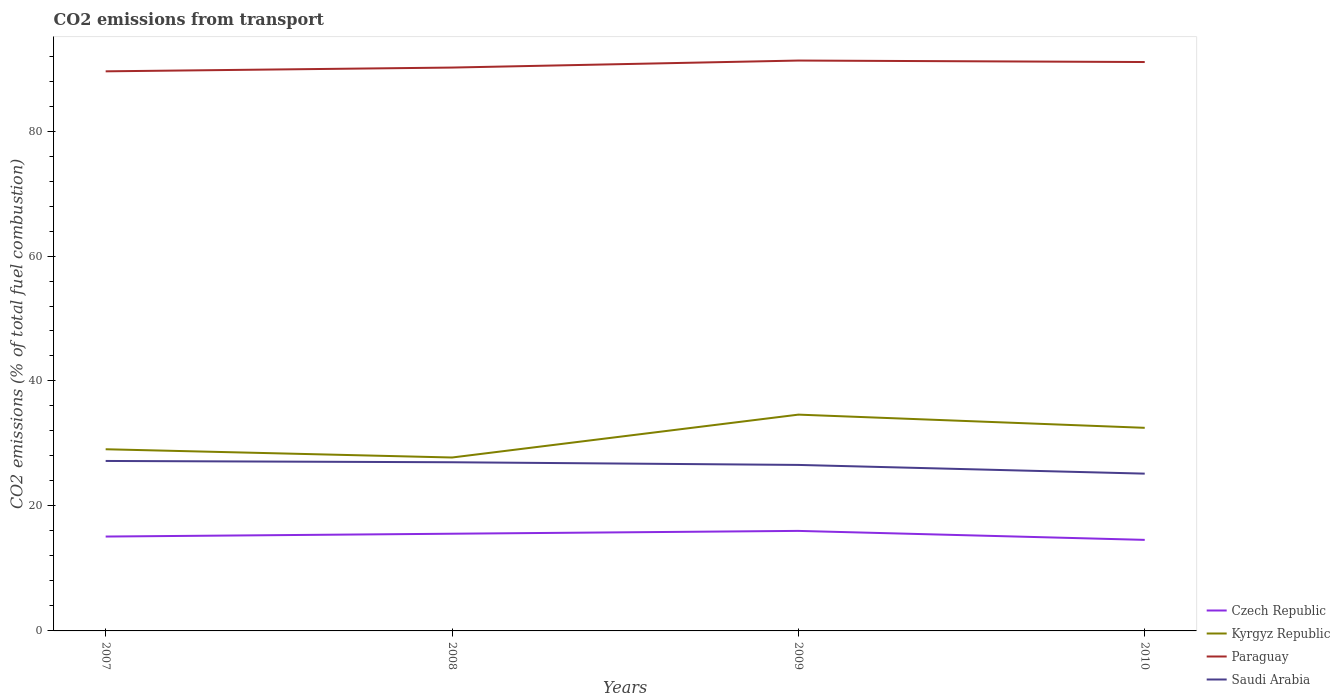How many different coloured lines are there?
Your answer should be compact. 4. Is the number of lines equal to the number of legend labels?
Your answer should be very brief. Yes. Across all years, what is the maximum total CO2 emitted in Saudi Arabia?
Offer a very short reply. 25.17. In which year was the total CO2 emitted in Czech Republic maximum?
Your response must be concise. 2010. What is the total total CO2 emitted in Czech Republic in the graph?
Your response must be concise. -0.45. What is the difference between the highest and the second highest total CO2 emitted in Saudi Arabia?
Provide a short and direct response. 2.03. How many years are there in the graph?
Make the answer very short. 4. Are the values on the major ticks of Y-axis written in scientific E-notation?
Make the answer very short. No. Does the graph contain any zero values?
Ensure brevity in your answer.  No. Does the graph contain grids?
Give a very brief answer. No. Where does the legend appear in the graph?
Provide a short and direct response. Bottom right. How many legend labels are there?
Keep it short and to the point. 4. How are the legend labels stacked?
Your response must be concise. Vertical. What is the title of the graph?
Keep it short and to the point. CO2 emissions from transport. What is the label or title of the X-axis?
Your answer should be very brief. Years. What is the label or title of the Y-axis?
Your answer should be compact. CO2 emissions (% of total fuel combustion). What is the CO2 emissions (% of total fuel combustion) in Czech Republic in 2007?
Your answer should be compact. 15.1. What is the CO2 emissions (% of total fuel combustion) in Kyrgyz Republic in 2007?
Offer a terse response. 29.08. What is the CO2 emissions (% of total fuel combustion) in Paraguay in 2007?
Provide a succinct answer. 89.56. What is the CO2 emissions (% of total fuel combustion) in Saudi Arabia in 2007?
Make the answer very short. 27.2. What is the CO2 emissions (% of total fuel combustion) in Czech Republic in 2008?
Your response must be concise. 15.56. What is the CO2 emissions (% of total fuel combustion) of Kyrgyz Republic in 2008?
Offer a terse response. 27.75. What is the CO2 emissions (% of total fuel combustion) in Paraguay in 2008?
Provide a short and direct response. 90.16. What is the CO2 emissions (% of total fuel combustion) of Saudi Arabia in 2008?
Offer a terse response. 26.99. What is the CO2 emissions (% of total fuel combustion) in Czech Republic in 2009?
Keep it short and to the point. 16.01. What is the CO2 emissions (% of total fuel combustion) of Kyrgyz Republic in 2009?
Provide a succinct answer. 34.62. What is the CO2 emissions (% of total fuel combustion) in Paraguay in 2009?
Provide a succinct answer. 91.28. What is the CO2 emissions (% of total fuel combustion) in Saudi Arabia in 2009?
Offer a terse response. 26.57. What is the CO2 emissions (% of total fuel combustion) of Czech Republic in 2010?
Keep it short and to the point. 14.57. What is the CO2 emissions (% of total fuel combustion) of Kyrgyz Republic in 2010?
Your answer should be compact. 32.5. What is the CO2 emissions (% of total fuel combustion) of Paraguay in 2010?
Give a very brief answer. 91.04. What is the CO2 emissions (% of total fuel combustion) in Saudi Arabia in 2010?
Your response must be concise. 25.17. Across all years, what is the maximum CO2 emissions (% of total fuel combustion) of Czech Republic?
Ensure brevity in your answer.  16.01. Across all years, what is the maximum CO2 emissions (% of total fuel combustion) of Kyrgyz Republic?
Provide a succinct answer. 34.62. Across all years, what is the maximum CO2 emissions (% of total fuel combustion) of Paraguay?
Give a very brief answer. 91.28. Across all years, what is the maximum CO2 emissions (% of total fuel combustion) in Saudi Arabia?
Give a very brief answer. 27.2. Across all years, what is the minimum CO2 emissions (% of total fuel combustion) of Czech Republic?
Make the answer very short. 14.57. Across all years, what is the minimum CO2 emissions (% of total fuel combustion) of Kyrgyz Republic?
Offer a very short reply. 27.75. Across all years, what is the minimum CO2 emissions (% of total fuel combustion) in Paraguay?
Your answer should be compact. 89.56. Across all years, what is the minimum CO2 emissions (% of total fuel combustion) of Saudi Arabia?
Provide a short and direct response. 25.17. What is the total CO2 emissions (% of total fuel combustion) in Czech Republic in the graph?
Your answer should be very brief. 61.24. What is the total CO2 emissions (% of total fuel combustion) of Kyrgyz Republic in the graph?
Ensure brevity in your answer.  123.95. What is the total CO2 emissions (% of total fuel combustion) in Paraguay in the graph?
Your response must be concise. 362.04. What is the total CO2 emissions (% of total fuel combustion) of Saudi Arabia in the graph?
Give a very brief answer. 105.93. What is the difference between the CO2 emissions (% of total fuel combustion) of Czech Republic in 2007 and that in 2008?
Keep it short and to the point. -0.45. What is the difference between the CO2 emissions (% of total fuel combustion) of Kyrgyz Republic in 2007 and that in 2008?
Ensure brevity in your answer.  1.32. What is the difference between the CO2 emissions (% of total fuel combustion) in Paraguay in 2007 and that in 2008?
Provide a succinct answer. -0.6. What is the difference between the CO2 emissions (% of total fuel combustion) of Saudi Arabia in 2007 and that in 2008?
Keep it short and to the point. 0.21. What is the difference between the CO2 emissions (% of total fuel combustion) in Czech Republic in 2007 and that in 2009?
Keep it short and to the point. -0.9. What is the difference between the CO2 emissions (% of total fuel combustion) in Kyrgyz Republic in 2007 and that in 2009?
Ensure brevity in your answer.  -5.54. What is the difference between the CO2 emissions (% of total fuel combustion) of Paraguay in 2007 and that in 2009?
Provide a short and direct response. -1.73. What is the difference between the CO2 emissions (% of total fuel combustion) in Saudi Arabia in 2007 and that in 2009?
Keep it short and to the point. 0.64. What is the difference between the CO2 emissions (% of total fuel combustion) of Czech Republic in 2007 and that in 2010?
Offer a very short reply. 0.53. What is the difference between the CO2 emissions (% of total fuel combustion) of Kyrgyz Republic in 2007 and that in 2010?
Ensure brevity in your answer.  -3.43. What is the difference between the CO2 emissions (% of total fuel combustion) in Paraguay in 2007 and that in 2010?
Ensure brevity in your answer.  -1.49. What is the difference between the CO2 emissions (% of total fuel combustion) of Saudi Arabia in 2007 and that in 2010?
Make the answer very short. 2.03. What is the difference between the CO2 emissions (% of total fuel combustion) in Czech Republic in 2008 and that in 2009?
Provide a short and direct response. -0.45. What is the difference between the CO2 emissions (% of total fuel combustion) in Kyrgyz Republic in 2008 and that in 2009?
Offer a terse response. -6.86. What is the difference between the CO2 emissions (% of total fuel combustion) in Paraguay in 2008 and that in 2009?
Your response must be concise. -1.12. What is the difference between the CO2 emissions (% of total fuel combustion) in Saudi Arabia in 2008 and that in 2009?
Provide a succinct answer. 0.43. What is the difference between the CO2 emissions (% of total fuel combustion) of Czech Republic in 2008 and that in 2010?
Your answer should be very brief. 0.99. What is the difference between the CO2 emissions (% of total fuel combustion) in Kyrgyz Republic in 2008 and that in 2010?
Provide a short and direct response. -4.75. What is the difference between the CO2 emissions (% of total fuel combustion) of Paraguay in 2008 and that in 2010?
Your answer should be very brief. -0.89. What is the difference between the CO2 emissions (% of total fuel combustion) of Saudi Arabia in 2008 and that in 2010?
Keep it short and to the point. 1.82. What is the difference between the CO2 emissions (% of total fuel combustion) of Czech Republic in 2009 and that in 2010?
Give a very brief answer. 1.44. What is the difference between the CO2 emissions (% of total fuel combustion) of Kyrgyz Republic in 2009 and that in 2010?
Provide a short and direct response. 2.11. What is the difference between the CO2 emissions (% of total fuel combustion) in Paraguay in 2009 and that in 2010?
Keep it short and to the point. 0.24. What is the difference between the CO2 emissions (% of total fuel combustion) in Saudi Arabia in 2009 and that in 2010?
Keep it short and to the point. 1.4. What is the difference between the CO2 emissions (% of total fuel combustion) in Czech Republic in 2007 and the CO2 emissions (% of total fuel combustion) in Kyrgyz Republic in 2008?
Your answer should be very brief. -12.65. What is the difference between the CO2 emissions (% of total fuel combustion) of Czech Republic in 2007 and the CO2 emissions (% of total fuel combustion) of Paraguay in 2008?
Offer a very short reply. -75.06. What is the difference between the CO2 emissions (% of total fuel combustion) in Czech Republic in 2007 and the CO2 emissions (% of total fuel combustion) in Saudi Arabia in 2008?
Give a very brief answer. -11.89. What is the difference between the CO2 emissions (% of total fuel combustion) in Kyrgyz Republic in 2007 and the CO2 emissions (% of total fuel combustion) in Paraguay in 2008?
Your answer should be compact. -61.08. What is the difference between the CO2 emissions (% of total fuel combustion) in Kyrgyz Republic in 2007 and the CO2 emissions (% of total fuel combustion) in Saudi Arabia in 2008?
Offer a very short reply. 2.08. What is the difference between the CO2 emissions (% of total fuel combustion) of Paraguay in 2007 and the CO2 emissions (% of total fuel combustion) of Saudi Arabia in 2008?
Give a very brief answer. 62.56. What is the difference between the CO2 emissions (% of total fuel combustion) of Czech Republic in 2007 and the CO2 emissions (% of total fuel combustion) of Kyrgyz Republic in 2009?
Offer a very short reply. -19.51. What is the difference between the CO2 emissions (% of total fuel combustion) in Czech Republic in 2007 and the CO2 emissions (% of total fuel combustion) in Paraguay in 2009?
Your response must be concise. -76.18. What is the difference between the CO2 emissions (% of total fuel combustion) in Czech Republic in 2007 and the CO2 emissions (% of total fuel combustion) in Saudi Arabia in 2009?
Make the answer very short. -11.46. What is the difference between the CO2 emissions (% of total fuel combustion) of Kyrgyz Republic in 2007 and the CO2 emissions (% of total fuel combustion) of Paraguay in 2009?
Keep it short and to the point. -62.21. What is the difference between the CO2 emissions (% of total fuel combustion) in Kyrgyz Republic in 2007 and the CO2 emissions (% of total fuel combustion) in Saudi Arabia in 2009?
Offer a terse response. 2.51. What is the difference between the CO2 emissions (% of total fuel combustion) in Paraguay in 2007 and the CO2 emissions (% of total fuel combustion) in Saudi Arabia in 2009?
Provide a short and direct response. 62.99. What is the difference between the CO2 emissions (% of total fuel combustion) in Czech Republic in 2007 and the CO2 emissions (% of total fuel combustion) in Kyrgyz Republic in 2010?
Offer a terse response. -17.4. What is the difference between the CO2 emissions (% of total fuel combustion) of Czech Republic in 2007 and the CO2 emissions (% of total fuel combustion) of Paraguay in 2010?
Provide a short and direct response. -75.94. What is the difference between the CO2 emissions (% of total fuel combustion) of Czech Republic in 2007 and the CO2 emissions (% of total fuel combustion) of Saudi Arabia in 2010?
Keep it short and to the point. -10.07. What is the difference between the CO2 emissions (% of total fuel combustion) in Kyrgyz Republic in 2007 and the CO2 emissions (% of total fuel combustion) in Paraguay in 2010?
Make the answer very short. -61.97. What is the difference between the CO2 emissions (% of total fuel combustion) in Kyrgyz Republic in 2007 and the CO2 emissions (% of total fuel combustion) in Saudi Arabia in 2010?
Make the answer very short. 3.91. What is the difference between the CO2 emissions (% of total fuel combustion) in Paraguay in 2007 and the CO2 emissions (% of total fuel combustion) in Saudi Arabia in 2010?
Offer a terse response. 64.39. What is the difference between the CO2 emissions (% of total fuel combustion) in Czech Republic in 2008 and the CO2 emissions (% of total fuel combustion) in Kyrgyz Republic in 2009?
Your response must be concise. -19.06. What is the difference between the CO2 emissions (% of total fuel combustion) of Czech Republic in 2008 and the CO2 emissions (% of total fuel combustion) of Paraguay in 2009?
Offer a terse response. -75.73. What is the difference between the CO2 emissions (% of total fuel combustion) in Czech Republic in 2008 and the CO2 emissions (% of total fuel combustion) in Saudi Arabia in 2009?
Offer a terse response. -11.01. What is the difference between the CO2 emissions (% of total fuel combustion) of Kyrgyz Republic in 2008 and the CO2 emissions (% of total fuel combustion) of Paraguay in 2009?
Provide a succinct answer. -63.53. What is the difference between the CO2 emissions (% of total fuel combustion) of Kyrgyz Republic in 2008 and the CO2 emissions (% of total fuel combustion) of Saudi Arabia in 2009?
Offer a very short reply. 1.19. What is the difference between the CO2 emissions (% of total fuel combustion) in Paraguay in 2008 and the CO2 emissions (% of total fuel combustion) in Saudi Arabia in 2009?
Your answer should be compact. 63.59. What is the difference between the CO2 emissions (% of total fuel combustion) in Czech Republic in 2008 and the CO2 emissions (% of total fuel combustion) in Kyrgyz Republic in 2010?
Make the answer very short. -16.95. What is the difference between the CO2 emissions (% of total fuel combustion) in Czech Republic in 2008 and the CO2 emissions (% of total fuel combustion) in Paraguay in 2010?
Give a very brief answer. -75.49. What is the difference between the CO2 emissions (% of total fuel combustion) in Czech Republic in 2008 and the CO2 emissions (% of total fuel combustion) in Saudi Arabia in 2010?
Offer a very short reply. -9.61. What is the difference between the CO2 emissions (% of total fuel combustion) of Kyrgyz Republic in 2008 and the CO2 emissions (% of total fuel combustion) of Paraguay in 2010?
Offer a terse response. -63.29. What is the difference between the CO2 emissions (% of total fuel combustion) in Kyrgyz Republic in 2008 and the CO2 emissions (% of total fuel combustion) in Saudi Arabia in 2010?
Give a very brief answer. 2.58. What is the difference between the CO2 emissions (% of total fuel combustion) of Paraguay in 2008 and the CO2 emissions (% of total fuel combustion) of Saudi Arabia in 2010?
Give a very brief answer. 64.99. What is the difference between the CO2 emissions (% of total fuel combustion) of Czech Republic in 2009 and the CO2 emissions (% of total fuel combustion) of Kyrgyz Republic in 2010?
Give a very brief answer. -16.5. What is the difference between the CO2 emissions (% of total fuel combustion) in Czech Republic in 2009 and the CO2 emissions (% of total fuel combustion) in Paraguay in 2010?
Your response must be concise. -75.04. What is the difference between the CO2 emissions (% of total fuel combustion) in Czech Republic in 2009 and the CO2 emissions (% of total fuel combustion) in Saudi Arabia in 2010?
Provide a short and direct response. -9.16. What is the difference between the CO2 emissions (% of total fuel combustion) in Kyrgyz Republic in 2009 and the CO2 emissions (% of total fuel combustion) in Paraguay in 2010?
Make the answer very short. -56.43. What is the difference between the CO2 emissions (% of total fuel combustion) in Kyrgyz Republic in 2009 and the CO2 emissions (% of total fuel combustion) in Saudi Arabia in 2010?
Offer a very short reply. 9.44. What is the difference between the CO2 emissions (% of total fuel combustion) in Paraguay in 2009 and the CO2 emissions (% of total fuel combustion) in Saudi Arabia in 2010?
Ensure brevity in your answer.  66.11. What is the average CO2 emissions (% of total fuel combustion) of Czech Republic per year?
Make the answer very short. 15.31. What is the average CO2 emissions (% of total fuel combustion) of Kyrgyz Republic per year?
Offer a very short reply. 30.99. What is the average CO2 emissions (% of total fuel combustion) of Paraguay per year?
Ensure brevity in your answer.  90.51. What is the average CO2 emissions (% of total fuel combustion) of Saudi Arabia per year?
Your answer should be compact. 26.48. In the year 2007, what is the difference between the CO2 emissions (% of total fuel combustion) in Czech Republic and CO2 emissions (% of total fuel combustion) in Kyrgyz Republic?
Ensure brevity in your answer.  -13.97. In the year 2007, what is the difference between the CO2 emissions (% of total fuel combustion) of Czech Republic and CO2 emissions (% of total fuel combustion) of Paraguay?
Make the answer very short. -74.45. In the year 2007, what is the difference between the CO2 emissions (% of total fuel combustion) of Czech Republic and CO2 emissions (% of total fuel combustion) of Saudi Arabia?
Ensure brevity in your answer.  -12.1. In the year 2007, what is the difference between the CO2 emissions (% of total fuel combustion) of Kyrgyz Republic and CO2 emissions (% of total fuel combustion) of Paraguay?
Your answer should be very brief. -60.48. In the year 2007, what is the difference between the CO2 emissions (% of total fuel combustion) in Kyrgyz Republic and CO2 emissions (% of total fuel combustion) in Saudi Arabia?
Provide a succinct answer. 1.87. In the year 2007, what is the difference between the CO2 emissions (% of total fuel combustion) in Paraguay and CO2 emissions (% of total fuel combustion) in Saudi Arabia?
Your answer should be very brief. 62.35. In the year 2008, what is the difference between the CO2 emissions (% of total fuel combustion) of Czech Republic and CO2 emissions (% of total fuel combustion) of Kyrgyz Republic?
Your answer should be compact. -12.2. In the year 2008, what is the difference between the CO2 emissions (% of total fuel combustion) of Czech Republic and CO2 emissions (% of total fuel combustion) of Paraguay?
Your answer should be compact. -74.6. In the year 2008, what is the difference between the CO2 emissions (% of total fuel combustion) of Czech Republic and CO2 emissions (% of total fuel combustion) of Saudi Arabia?
Keep it short and to the point. -11.44. In the year 2008, what is the difference between the CO2 emissions (% of total fuel combustion) of Kyrgyz Republic and CO2 emissions (% of total fuel combustion) of Paraguay?
Provide a short and direct response. -62.41. In the year 2008, what is the difference between the CO2 emissions (% of total fuel combustion) of Kyrgyz Republic and CO2 emissions (% of total fuel combustion) of Saudi Arabia?
Ensure brevity in your answer.  0.76. In the year 2008, what is the difference between the CO2 emissions (% of total fuel combustion) in Paraguay and CO2 emissions (% of total fuel combustion) in Saudi Arabia?
Keep it short and to the point. 63.17. In the year 2009, what is the difference between the CO2 emissions (% of total fuel combustion) of Czech Republic and CO2 emissions (% of total fuel combustion) of Kyrgyz Republic?
Offer a terse response. -18.61. In the year 2009, what is the difference between the CO2 emissions (% of total fuel combustion) of Czech Republic and CO2 emissions (% of total fuel combustion) of Paraguay?
Offer a terse response. -75.28. In the year 2009, what is the difference between the CO2 emissions (% of total fuel combustion) in Czech Republic and CO2 emissions (% of total fuel combustion) in Saudi Arabia?
Make the answer very short. -10.56. In the year 2009, what is the difference between the CO2 emissions (% of total fuel combustion) in Kyrgyz Republic and CO2 emissions (% of total fuel combustion) in Paraguay?
Provide a short and direct response. -56.67. In the year 2009, what is the difference between the CO2 emissions (% of total fuel combustion) of Kyrgyz Republic and CO2 emissions (% of total fuel combustion) of Saudi Arabia?
Give a very brief answer. 8.05. In the year 2009, what is the difference between the CO2 emissions (% of total fuel combustion) of Paraguay and CO2 emissions (% of total fuel combustion) of Saudi Arabia?
Ensure brevity in your answer.  64.72. In the year 2010, what is the difference between the CO2 emissions (% of total fuel combustion) in Czech Republic and CO2 emissions (% of total fuel combustion) in Kyrgyz Republic?
Keep it short and to the point. -17.93. In the year 2010, what is the difference between the CO2 emissions (% of total fuel combustion) in Czech Republic and CO2 emissions (% of total fuel combustion) in Paraguay?
Offer a terse response. -76.47. In the year 2010, what is the difference between the CO2 emissions (% of total fuel combustion) in Kyrgyz Republic and CO2 emissions (% of total fuel combustion) in Paraguay?
Your answer should be compact. -58.54. In the year 2010, what is the difference between the CO2 emissions (% of total fuel combustion) of Kyrgyz Republic and CO2 emissions (% of total fuel combustion) of Saudi Arabia?
Your answer should be very brief. 7.33. In the year 2010, what is the difference between the CO2 emissions (% of total fuel combustion) in Paraguay and CO2 emissions (% of total fuel combustion) in Saudi Arabia?
Provide a succinct answer. 65.87. What is the ratio of the CO2 emissions (% of total fuel combustion) of Czech Republic in 2007 to that in 2008?
Provide a succinct answer. 0.97. What is the ratio of the CO2 emissions (% of total fuel combustion) of Kyrgyz Republic in 2007 to that in 2008?
Give a very brief answer. 1.05. What is the ratio of the CO2 emissions (% of total fuel combustion) of Paraguay in 2007 to that in 2008?
Give a very brief answer. 0.99. What is the ratio of the CO2 emissions (% of total fuel combustion) of Saudi Arabia in 2007 to that in 2008?
Offer a terse response. 1.01. What is the ratio of the CO2 emissions (% of total fuel combustion) of Czech Republic in 2007 to that in 2009?
Offer a terse response. 0.94. What is the ratio of the CO2 emissions (% of total fuel combustion) in Kyrgyz Republic in 2007 to that in 2009?
Your response must be concise. 0.84. What is the ratio of the CO2 emissions (% of total fuel combustion) in Paraguay in 2007 to that in 2009?
Make the answer very short. 0.98. What is the ratio of the CO2 emissions (% of total fuel combustion) of Czech Republic in 2007 to that in 2010?
Offer a terse response. 1.04. What is the ratio of the CO2 emissions (% of total fuel combustion) of Kyrgyz Republic in 2007 to that in 2010?
Give a very brief answer. 0.89. What is the ratio of the CO2 emissions (% of total fuel combustion) in Paraguay in 2007 to that in 2010?
Offer a very short reply. 0.98. What is the ratio of the CO2 emissions (% of total fuel combustion) of Saudi Arabia in 2007 to that in 2010?
Give a very brief answer. 1.08. What is the ratio of the CO2 emissions (% of total fuel combustion) in Czech Republic in 2008 to that in 2009?
Provide a short and direct response. 0.97. What is the ratio of the CO2 emissions (% of total fuel combustion) in Kyrgyz Republic in 2008 to that in 2009?
Your response must be concise. 0.8. What is the ratio of the CO2 emissions (% of total fuel combustion) in Saudi Arabia in 2008 to that in 2009?
Your answer should be compact. 1.02. What is the ratio of the CO2 emissions (% of total fuel combustion) in Czech Republic in 2008 to that in 2010?
Your answer should be compact. 1.07. What is the ratio of the CO2 emissions (% of total fuel combustion) of Kyrgyz Republic in 2008 to that in 2010?
Keep it short and to the point. 0.85. What is the ratio of the CO2 emissions (% of total fuel combustion) in Paraguay in 2008 to that in 2010?
Provide a succinct answer. 0.99. What is the ratio of the CO2 emissions (% of total fuel combustion) in Saudi Arabia in 2008 to that in 2010?
Ensure brevity in your answer.  1.07. What is the ratio of the CO2 emissions (% of total fuel combustion) of Czech Republic in 2009 to that in 2010?
Provide a short and direct response. 1.1. What is the ratio of the CO2 emissions (% of total fuel combustion) of Kyrgyz Republic in 2009 to that in 2010?
Give a very brief answer. 1.06. What is the ratio of the CO2 emissions (% of total fuel combustion) of Saudi Arabia in 2009 to that in 2010?
Ensure brevity in your answer.  1.06. What is the difference between the highest and the second highest CO2 emissions (% of total fuel combustion) in Czech Republic?
Keep it short and to the point. 0.45. What is the difference between the highest and the second highest CO2 emissions (% of total fuel combustion) in Kyrgyz Republic?
Give a very brief answer. 2.11. What is the difference between the highest and the second highest CO2 emissions (% of total fuel combustion) of Paraguay?
Keep it short and to the point. 0.24. What is the difference between the highest and the second highest CO2 emissions (% of total fuel combustion) in Saudi Arabia?
Your response must be concise. 0.21. What is the difference between the highest and the lowest CO2 emissions (% of total fuel combustion) in Czech Republic?
Offer a very short reply. 1.44. What is the difference between the highest and the lowest CO2 emissions (% of total fuel combustion) in Kyrgyz Republic?
Your answer should be compact. 6.86. What is the difference between the highest and the lowest CO2 emissions (% of total fuel combustion) of Paraguay?
Your response must be concise. 1.73. What is the difference between the highest and the lowest CO2 emissions (% of total fuel combustion) of Saudi Arabia?
Your answer should be compact. 2.03. 